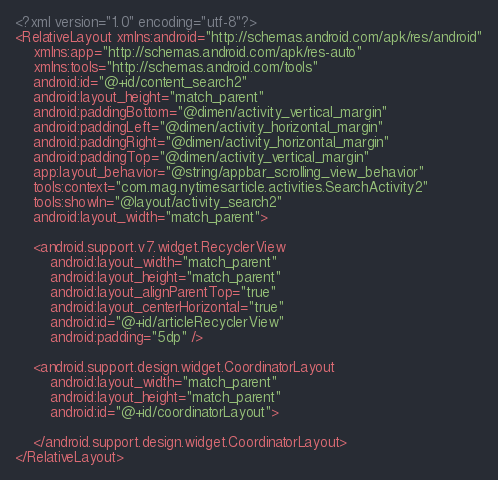Convert code to text. <code><loc_0><loc_0><loc_500><loc_500><_XML_><?xml version="1.0" encoding="utf-8"?>
<RelativeLayout xmlns:android="http://schemas.android.com/apk/res/android"
    xmlns:app="http://schemas.android.com/apk/res-auto"
    xmlns:tools="http://schemas.android.com/tools"
    android:id="@+id/content_search2"
    android:layout_height="match_parent"
    android:paddingBottom="@dimen/activity_vertical_margin"
    android:paddingLeft="@dimen/activity_horizontal_margin"
    android:paddingRight="@dimen/activity_horizontal_margin"
    android:paddingTop="@dimen/activity_vertical_margin"
    app:layout_behavior="@string/appbar_scrolling_view_behavior"
    tools:context="com.mag.nytimesarticle.activities.SearchActivity2"
    tools:showIn="@layout/activity_search2"
    android:layout_width="match_parent">

    <android.support.v7.widget.RecyclerView
        android:layout_width="match_parent"
        android:layout_height="match_parent"
        android:layout_alignParentTop="true"
        android:layout_centerHorizontal="true"
        android:id="@+id/articleRecyclerView"
        android:padding="5dp" />

    <android.support.design.widget.CoordinatorLayout
        android:layout_width="match_parent"
        android:layout_height="match_parent"
        android:id="@+id/coordinatorLayout">

    </android.support.design.widget.CoordinatorLayout>
</RelativeLayout>
</code> 